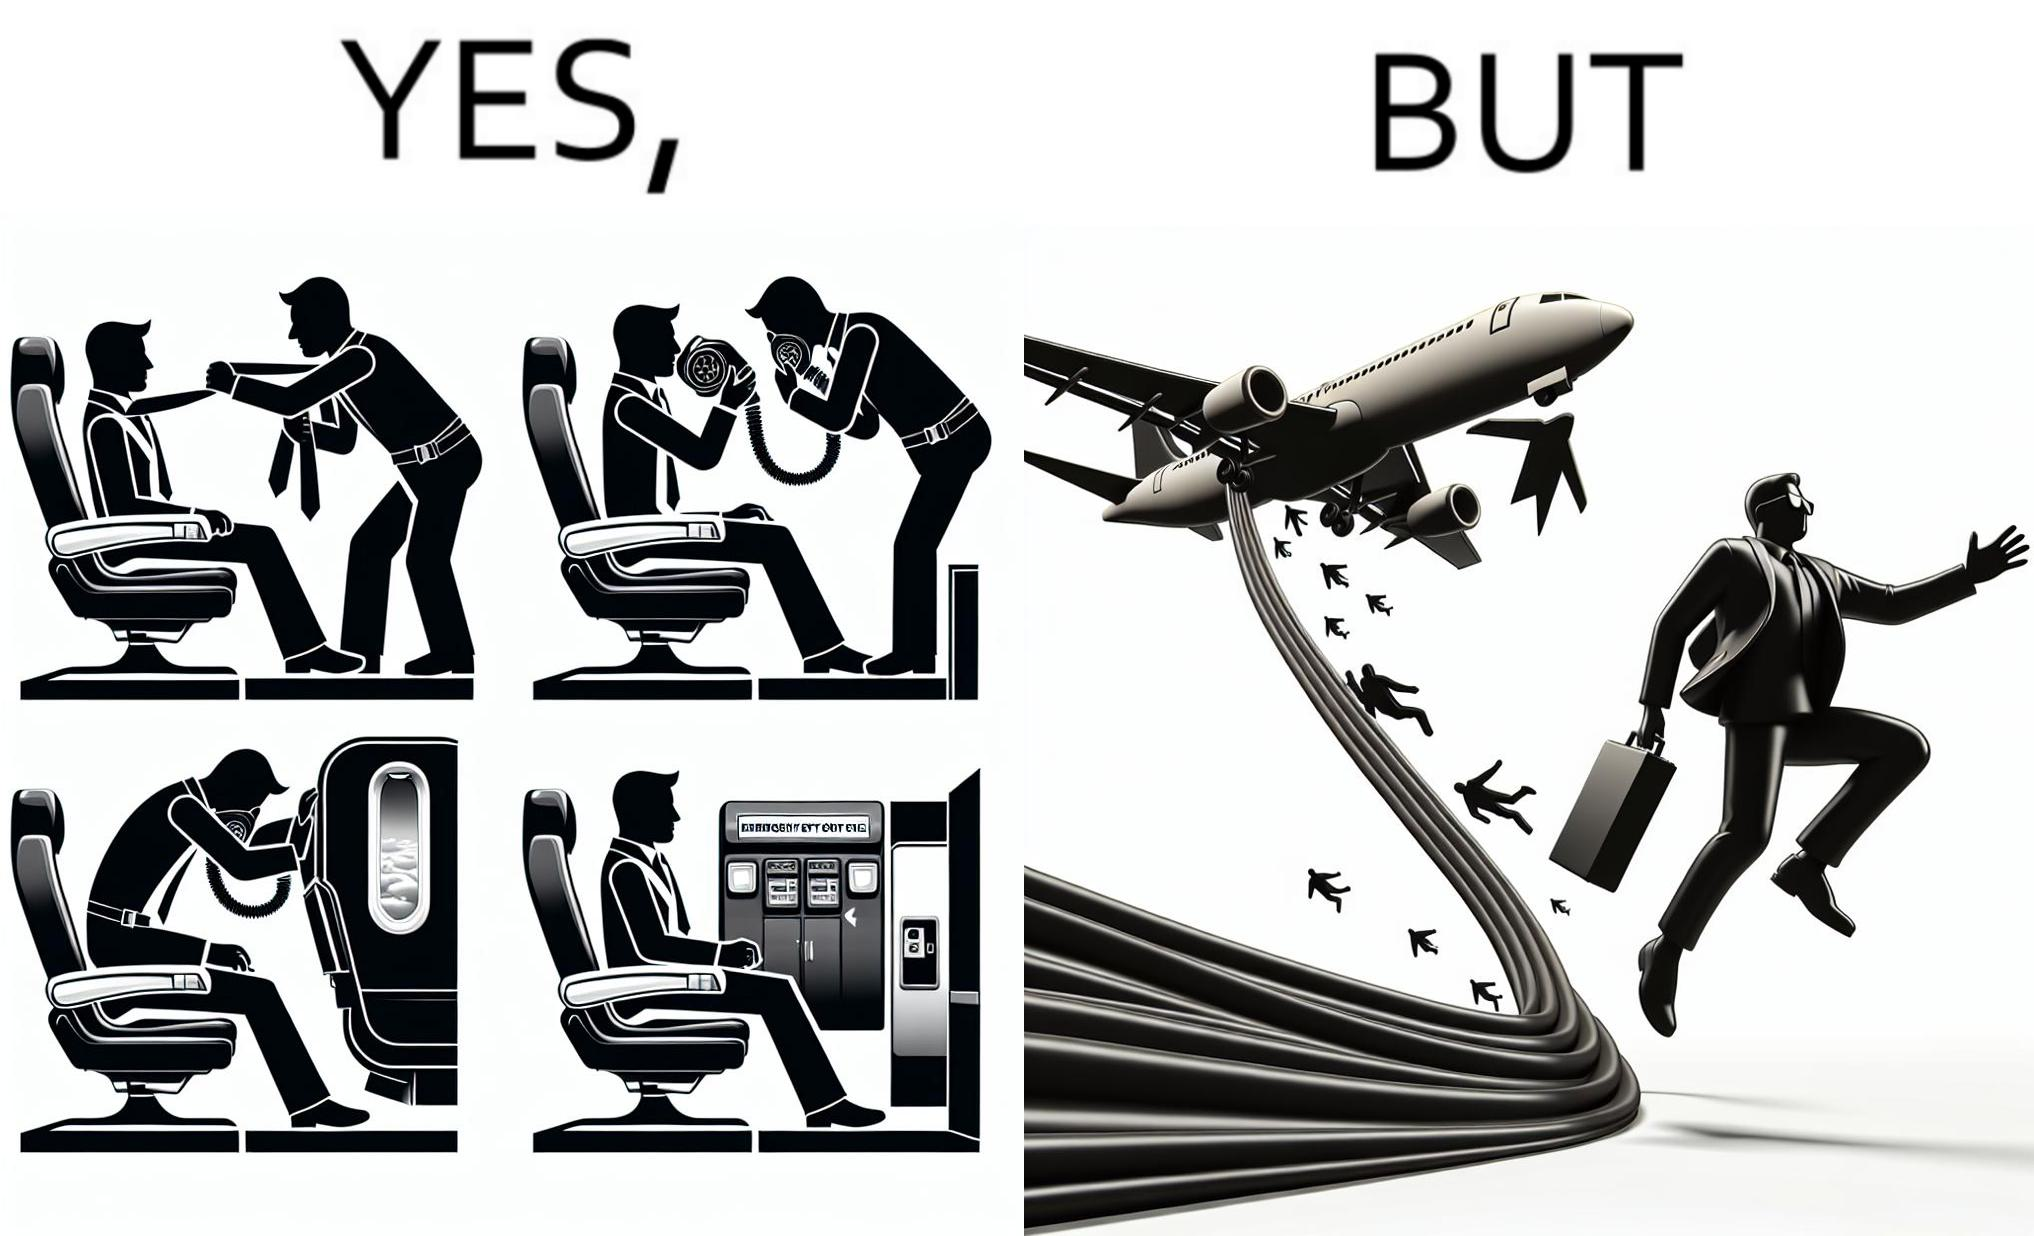What makes this image funny or satirical? These images are funny since it shows how we are taught emergency procedures to follow in case of an accident while in an airplane but how none of them work if the plane is still in air 